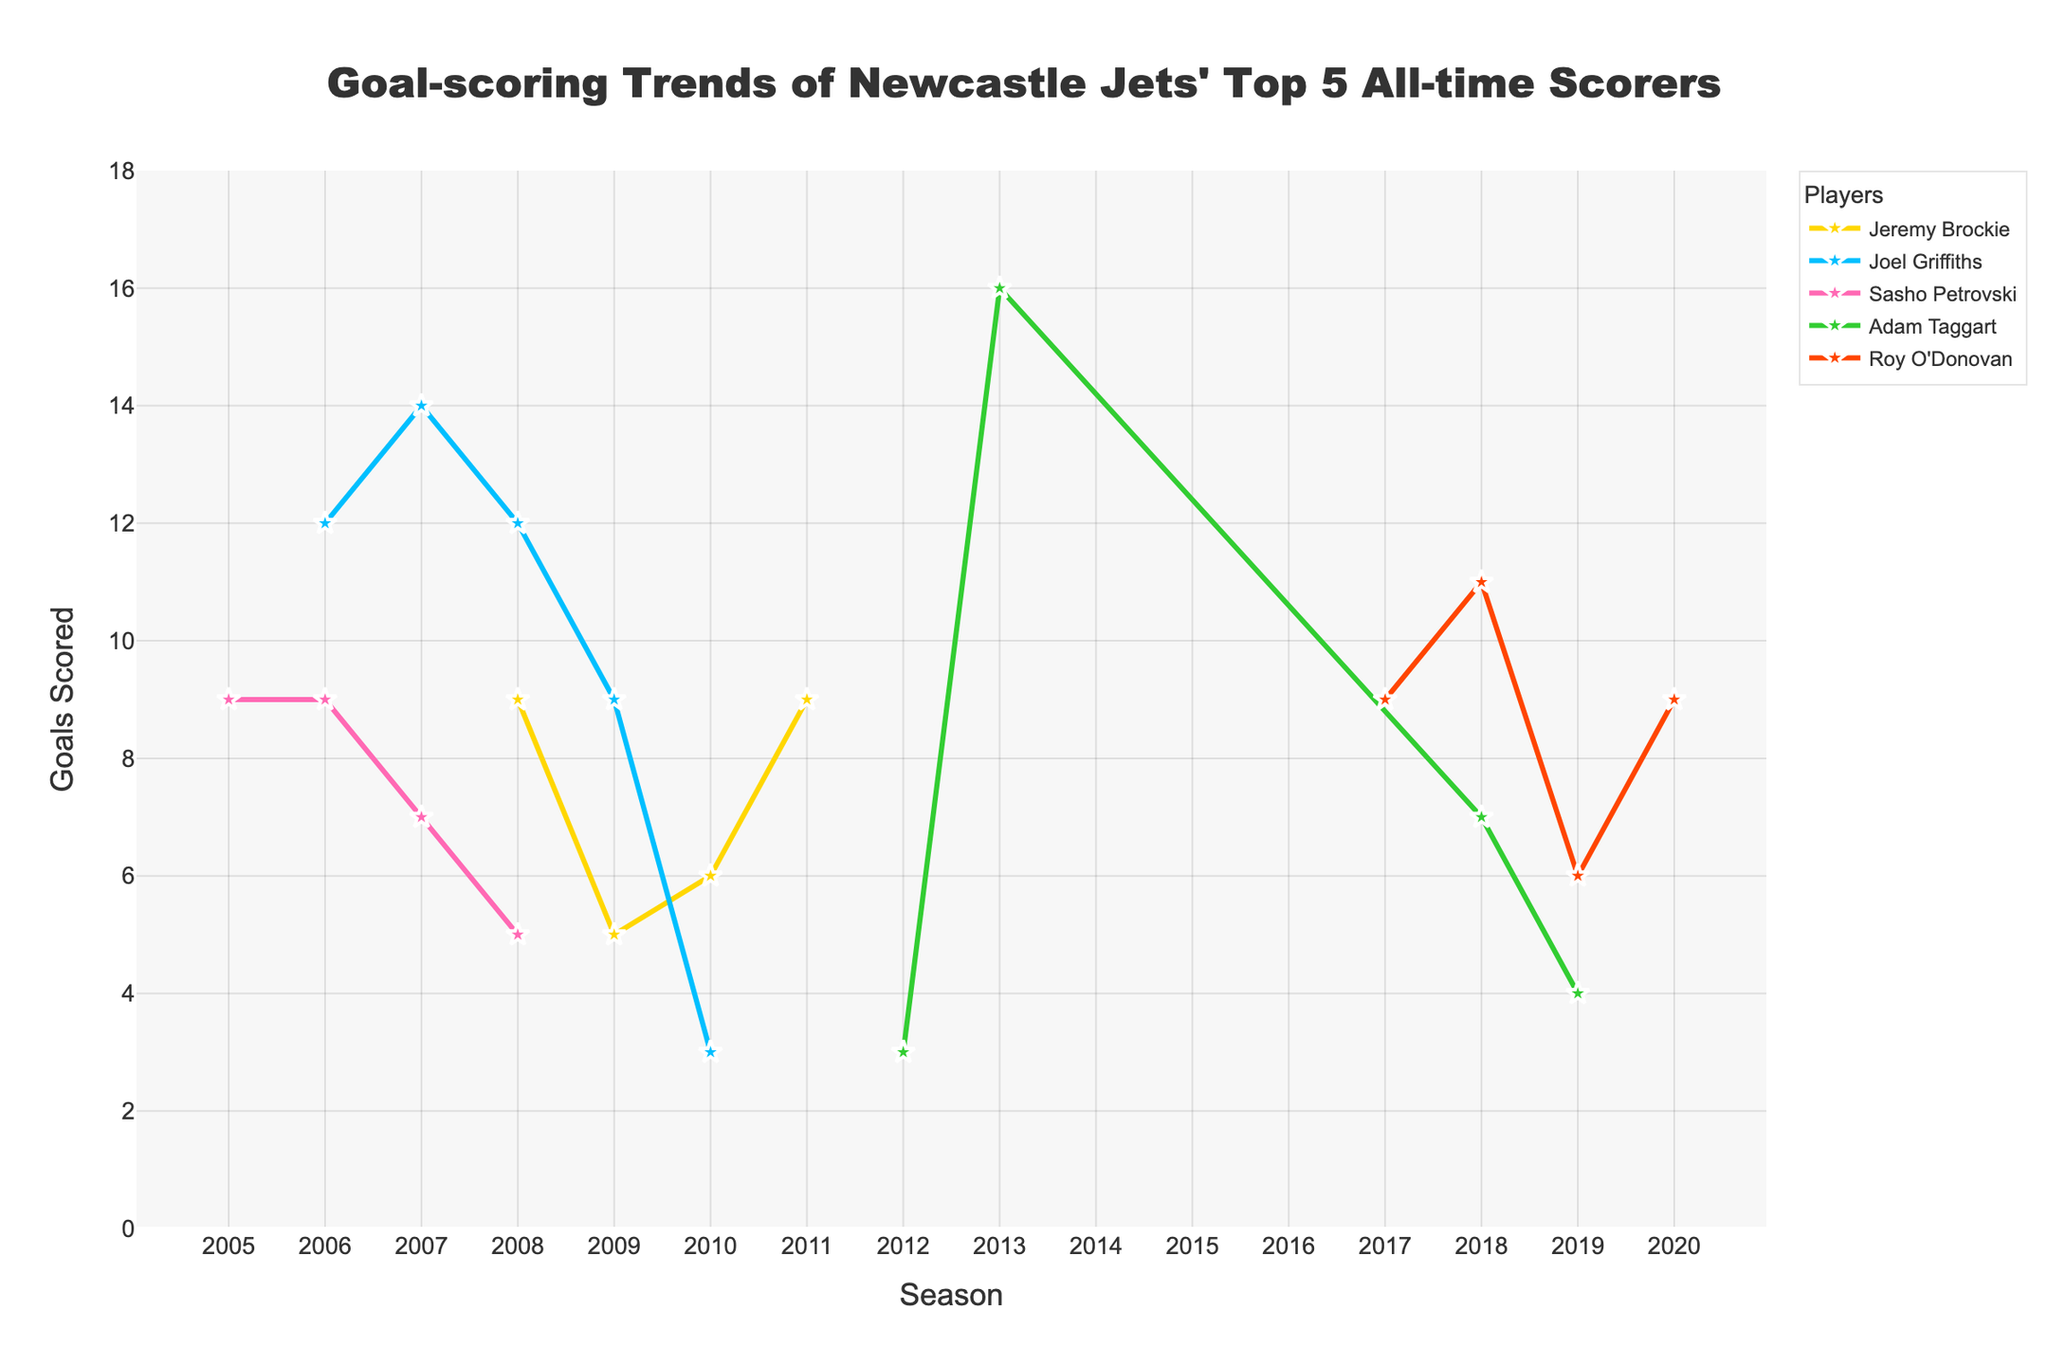1. Which player had the highest goal-scoring season, and how many goals did he score? By looking at the lines and markers, the highest marker (in terms of goals scored in a single season) reaches 16 goals, which belongs to Adam Taggart in the 2013-14 season.
Answer: Adam Taggart, 16 2. What is the total number of goals scored by Jeremy Brockie across all seasons? Add up the goals scored by Jeremy Brockie in each season: 9 + 5 + 6 + 9, which sums up to 29 goals.
Answer: 29 3. Who had more consistent scoring seasons, Joel Griffiths or Roy O'Donovan, and why? Compare the variations in goals scored by Joel Griffiths and Roy O'Donovan across their seasons. Joel Griffiths' goals range from 3 to 14 with large differences, while Roy O'Donovan's goals range from 6 to 11 with smaller differences. Therefore, Roy O'Donovan had more consistent scoring seasons.
Answer: Roy O'Donovan, smaller variation 4. In which season did Sasho Petrovski score his highest, and how many goals did he score? Look at the peak of the line corresponding to Sasho Petrovski. The highest point is in the 2005-06 and 2006-07 seasons where he scored 9 goals each.
Answer: 2005-06 and 2006-07, 9 goals 5. Did any player score exactly 9 goals in a season more than once? If so, who and in which seasons? Check the graph for players who have a marker at the 9-goal level in multiple seasons. Jeremy Brockie scored 9 goals in the 2008-09 and 2011-12 seasons, and Roy O'Donovan scored 9 goals in the 2017-18 and 2020-21 seasons.
Answer: Jeremy Brockie (2008-09, 2011-12), Roy O'Donovan (2017-18, 2020-21) 6. Calculate the average goals per season for Adam Taggart. Add Adam Taggart's goals across all seasons: 3 + 16 + 7 + 4, which equals 30 goals. Divide by the number of seasons (4): 30/4 = 7.5.
Answer: 7.5 7. Compare the goal trends of Joel Griffiths and Jeremy Brockie. Who had a declining trend in the last few seasons? Observe the goals scored by Joel Griffiths and Jeremy Brockie over the seasons. Joel Griffiths had a notable decline in his last seasons from 12, 14 to 3 goals. Jeremy Brockie had fluctuations but ended with 9 goals.
Answer: Joel Griffiths 8. Across all players, who scored the least number of goals in a single season, and how many goals? Look for the lowest marker in the chart, which is at 3 goals by Joel Griffiths in the 2010-11 season and by Adam Taggart in the 2012-13 season.
Answer: Joel Griffiths, Adam Taggart, 3 9. How many goals did Newcastle Jets' top 5 scorers accumulate during their best seasons combined? Identify the highest goal-scoring season for each player: Jeremy Brockie (9), Joel Griffiths (14), Sasho Petrovski (9), Adam Taggart (16), Roy O'Donovan (11). Sum these numbers: 9 + 14 + 9 + 16 + 11 = 59.
Answer: 59 10. Which player’s goal performance had the most improvement from one season to the next, and during which seasons did this occur? Calculate the goal differences between consecutive seasons for each player. Adam Taggart improved from 3 goals in 2012-13 to 16 in 2013-14, an increase of 13 goals, which is the highest improvement observed.
Answer: Adam Taggart, 2012-13 to 2013-14, 13 